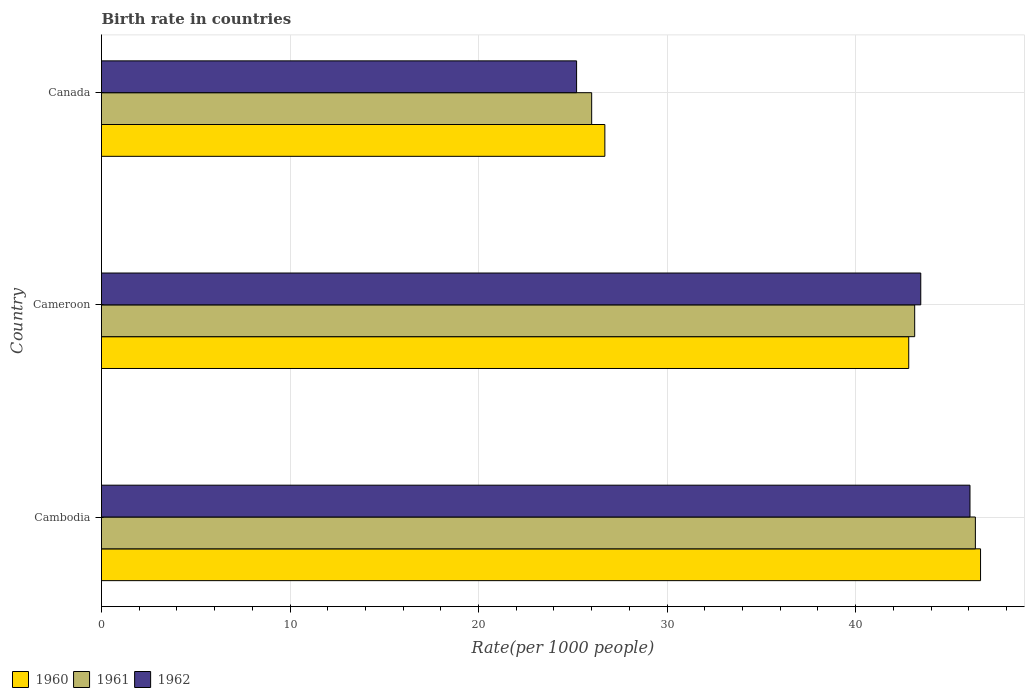How many different coloured bars are there?
Ensure brevity in your answer.  3. How many groups of bars are there?
Offer a terse response. 3. Are the number of bars per tick equal to the number of legend labels?
Your answer should be very brief. Yes. Are the number of bars on each tick of the Y-axis equal?
Keep it short and to the point. Yes. What is the label of the 2nd group of bars from the top?
Your answer should be compact. Cameroon. What is the birth rate in 1960 in Canada?
Your answer should be very brief. 26.7. Across all countries, what is the maximum birth rate in 1961?
Provide a succinct answer. 46.35. Across all countries, what is the minimum birth rate in 1960?
Give a very brief answer. 26.7. In which country was the birth rate in 1960 maximum?
Provide a short and direct response. Cambodia. What is the total birth rate in 1960 in the graph?
Make the answer very short. 116.15. What is the difference between the birth rate in 1960 in Cameroon and that in Canada?
Your response must be concise. 16.12. What is the difference between the birth rate in 1960 in Canada and the birth rate in 1961 in Cambodia?
Ensure brevity in your answer.  -19.65. What is the average birth rate in 1961 per country?
Your answer should be very brief. 38.5. What is the difference between the birth rate in 1960 and birth rate in 1961 in Cambodia?
Provide a short and direct response. 0.27. What is the ratio of the birth rate in 1962 in Cambodia to that in Cameroon?
Offer a very short reply. 1.06. Is the birth rate in 1960 in Cambodia less than that in Cameroon?
Offer a terse response. No. What is the difference between the highest and the second highest birth rate in 1960?
Provide a short and direct response. 3.81. What is the difference between the highest and the lowest birth rate in 1961?
Ensure brevity in your answer.  20.35. In how many countries, is the birth rate in 1961 greater than the average birth rate in 1961 taken over all countries?
Keep it short and to the point. 2. What does the 3rd bar from the top in Cambodia represents?
Provide a succinct answer. 1960. What does the 1st bar from the bottom in Cameroon represents?
Give a very brief answer. 1960. Are all the bars in the graph horizontal?
Offer a very short reply. Yes. What is the difference between two consecutive major ticks on the X-axis?
Offer a terse response. 10. Are the values on the major ticks of X-axis written in scientific E-notation?
Provide a succinct answer. No. Where does the legend appear in the graph?
Your response must be concise. Bottom left. What is the title of the graph?
Provide a short and direct response. Birth rate in countries. Does "1985" appear as one of the legend labels in the graph?
Your answer should be compact. No. What is the label or title of the X-axis?
Your answer should be very brief. Rate(per 1000 people). What is the Rate(per 1000 people) in 1960 in Cambodia?
Offer a terse response. 46.63. What is the Rate(per 1000 people) of 1961 in Cambodia?
Your answer should be compact. 46.35. What is the Rate(per 1000 people) of 1962 in Cambodia?
Your answer should be compact. 46.07. What is the Rate(per 1000 people) of 1960 in Cameroon?
Give a very brief answer. 42.82. What is the Rate(per 1000 people) in 1961 in Cameroon?
Ensure brevity in your answer.  43.13. What is the Rate(per 1000 people) of 1962 in Cameroon?
Your answer should be very brief. 43.46. What is the Rate(per 1000 people) in 1960 in Canada?
Your answer should be compact. 26.7. What is the Rate(per 1000 people) of 1961 in Canada?
Provide a short and direct response. 26. What is the Rate(per 1000 people) of 1962 in Canada?
Keep it short and to the point. 25.2. Across all countries, what is the maximum Rate(per 1000 people) in 1960?
Make the answer very short. 46.63. Across all countries, what is the maximum Rate(per 1000 people) in 1961?
Your answer should be very brief. 46.35. Across all countries, what is the maximum Rate(per 1000 people) of 1962?
Your answer should be very brief. 46.07. Across all countries, what is the minimum Rate(per 1000 people) in 1960?
Keep it short and to the point. 26.7. Across all countries, what is the minimum Rate(per 1000 people) of 1962?
Keep it short and to the point. 25.2. What is the total Rate(per 1000 people) of 1960 in the graph?
Offer a terse response. 116.14. What is the total Rate(per 1000 people) of 1961 in the graph?
Your answer should be compact. 115.49. What is the total Rate(per 1000 people) of 1962 in the graph?
Your response must be concise. 114.72. What is the difference between the Rate(per 1000 people) of 1960 in Cambodia and that in Cameroon?
Ensure brevity in your answer.  3.81. What is the difference between the Rate(per 1000 people) in 1961 in Cambodia and that in Cameroon?
Provide a short and direct response. 3.22. What is the difference between the Rate(per 1000 people) in 1962 in Cambodia and that in Cameroon?
Give a very brief answer. 2.61. What is the difference between the Rate(per 1000 people) in 1960 in Cambodia and that in Canada?
Ensure brevity in your answer.  19.93. What is the difference between the Rate(per 1000 people) of 1961 in Cambodia and that in Canada?
Ensure brevity in your answer.  20.35. What is the difference between the Rate(per 1000 people) in 1962 in Cambodia and that in Canada?
Your answer should be very brief. 20.87. What is the difference between the Rate(per 1000 people) of 1960 in Cameroon and that in Canada?
Make the answer very short. 16.12. What is the difference between the Rate(per 1000 people) of 1961 in Cameroon and that in Canada?
Make the answer very short. 17.13. What is the difference between the Rate(per 1000 people) of 1962 in Cameroon and that in Canada?
Make the answer very short. 18.26. What is the difference between the Rate(per 1000 people) of 1960 in Cambodia and the Rate(per 1000 people) of 1961 in Cameroon?
Make the answer very short. 3.49. What is the difference between the Rate(per 1000 people) in 1960 in Cambodia and the Rate(per 1000 people) in 1962 in Cameroon?
Ensure brevity in your answer.  3.17. What is the difference between the Rate(per 1000 people) of 1961 in Cambodia and the Rate(per 1000 people) of 1962 in Cameroon?
Ensure brevity in your answer.  2.9. What is the difference between the Rate(per 1000 people) in 1960 in Cambodia and the Rate(per 1000 people) in 1961 in Canada?
Make the answer very short. 20.63. What is the difference between the Rate(per 1000 people) in 1960 in Cambodia and the Rate(per 1000 people) in 1962 in Canada?
Make the answer very short. 21.43. What is the difference between the Rate(per 1000 people) in 1961 in Cambodia and the Rate(per 1000 people) in 1962 in Canada?
Keep it short and to the point. 21.15. What is the difference between the Rate(per 1000 people) in 1960 in Cameroon and the Rate(per 1000 people) in 1961 in Canada?
Ensure brevity in your answer.  16.82. What is the difference between the Rate(per 1000 people) of 1960 in Cameroon and the Rate(per 1000 people) of 1962 in Canada?
Ensure brevity in your answer.  17.62. What is the difference between the Rate(per 1000 people) in 1961 in Cameroon and the Rate(per 1000 people) in 1962 in Canada?
Your answer should be very brief. 17.93. What is the average Rate(per 1000 people) in 1960 per country?
Your response must be concise. 38.72. What is the average Rate(per 1000 people) of 1961 per country?
Your answer should be very brief. 38.5. What is the average Rate(per 1000 people) of 1962 per country?
Ensure brevity in your answer.  38.24. What is the difference between the Rate(per 1000 people) in 1960 and Rate(per 1000 people) in 1961 in Cambodia?
Your answer should be compact. 0.27. What is the difference between the Rate(per 1000 people) in 1960 and Rate(per 1000 people) in 1962 in Cambodia?
Provide a succinct answer. 0.56. What is the difference between the Rate(per 1000 people) in 1961 and Rate(per 1000 people) in 1962 in Cambodia?
Keep it short and to the point. 0.29. What is the difference between the Rate(per 1000 people) of 1960 and Rate(per 1000 people) of 1961 in Cameroon?
Make the answer very short. -0.32. What is the difference between the Rate(per 1000 people) of 1960 and Rate(per 1000 people) of 1962 in Cameroon?
Offer a very short reply. -0.64. What is the difference between the Rate(per 1000 people) in 1961 and Rate(per 1000 people) in 1962 in Cameroon?
Your answer should be very brief. -0.32. What is the difference between the Rate(per 1000 people) in 1960 and Rate(per 1000 people) in 1962 in Canada?
Your answer should be very brief. 1.5. What is the ratio of the Rate(per 1000 people) in 1960 in Cambodia to that in Cameroon?
Your response must be concise. 1.09. What is the ratio of the Rate(per 1000 people) in 1961 in Cambodia to that in Cameroon?
Keep it short and to the point. 1.07. What is the ratio of the Rate(per 1000 people) of 1962 in Cambodia to that in Cameroon?
Your answer should be very brief. 1.06. What is the ratio of the Rate(per 1000 people) in 1960 in Cambodia to that in Canada?
Offer a terse response. 1.75. What is the ratio of the Rate(per 1000 people) in 1961 in Cambodia to that in Canada?
Provide a short and direct response. 1.78. What is the ratio of the Rate(per 1000 people) of 1962 in Cambodia to that in Canada?
Make the answer very short. 1.83. What is the ratio of the Rate(per 1000 people) of 1960 in Cameroon to that in Canada?
Your answer should be very brief. 1.6. What is the ratio of the Rate(per 1000 people) in 1961 in Cameroon to that in Canada?
Your answer should be compact. 1.66. What is the ratio of the Rate(per 1000 people) of 1962 in Cameroon to that in Canada?
Your answer should be compact. 1.72. What is the difference between the highest and the second highest Rate(per 1000 people) in 1960?
Give a very brief answer. 3.81. What is the difference between the highest and the second highest Rate(per 1000 people) of 1961?
Your response must be concise. 3.22. What is the difference between the highest and the second highest Rate(per 1000 people) of 1962?
Your answer should be compact. 2.61. What is the difference between the highest and the lowest Rate(per 1000 people) in 1960?
Make the answer very short. 19.93. What is the difference between the highest and the lowest Rate(per 1000 people) in 1961?
Your answer should be very brief. 20.35. What is the difference between the highest and the lowest Rate(per 1000 people) in 1962?
Keep it short and to the point. 20.87. 